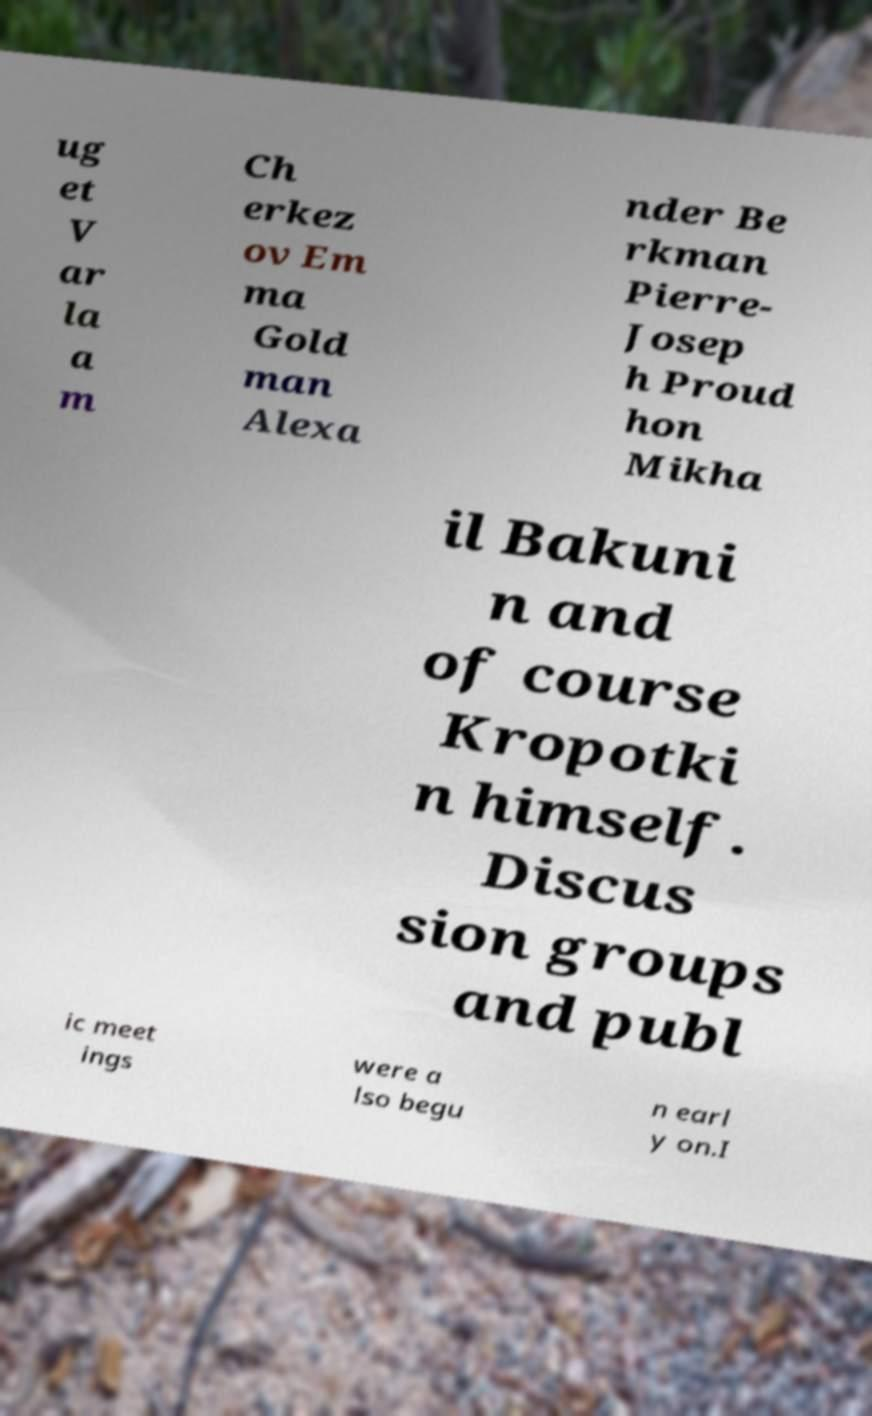What messages or text are displayed in this image? I need them in a readable, typed format. ug et V ar la a m Ch erkez ov Em ma Gold man Alexa nder Be rkman Pierre- Josep h Proud hon Mikha il Bakuni n and of course Kropotki n himself. Discus sion groups and publ ic meet ings were a lso begu n earl y on.I 